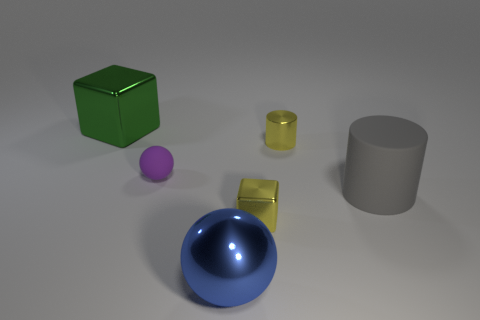There is a thing that is the same color as the small block; what is it made of?
Provide a succinct answer. Metal. Is the material of the big cube the same as the small purple ball?
Ensure brevity in your answer.  No. How many things are metallic blocks behind the metallic cylinder or large objects that are on the left side of the purple object?
Your response must be concise. 1. There is another object that is the same shape as the large green shiny thing; what color is it?
Your answer should be compact. Yellow. How many large rubber cylinders have the same color as the shiny cylinder?
Ensure brevity in your answer.  0. Is the rubber ball the same color as the big sphere?
Provide a short and direct response. No. What number of things are either things that are left of the big blue shiny sphere or red metallic spheres?
Your answer should be very brief. 2. There is a sphere that is behind the block on the right side of the big metal object that is to the left of the metallic sphere; what color is it?
Your answer should be very brief. Purple. What is the color of the tiny block that is made of the same material as the big blue sphere?
Offer a very short reply. Yellow. What number of big gray objects have the same material as the purple thing?
Your answer should be compact. 1. 